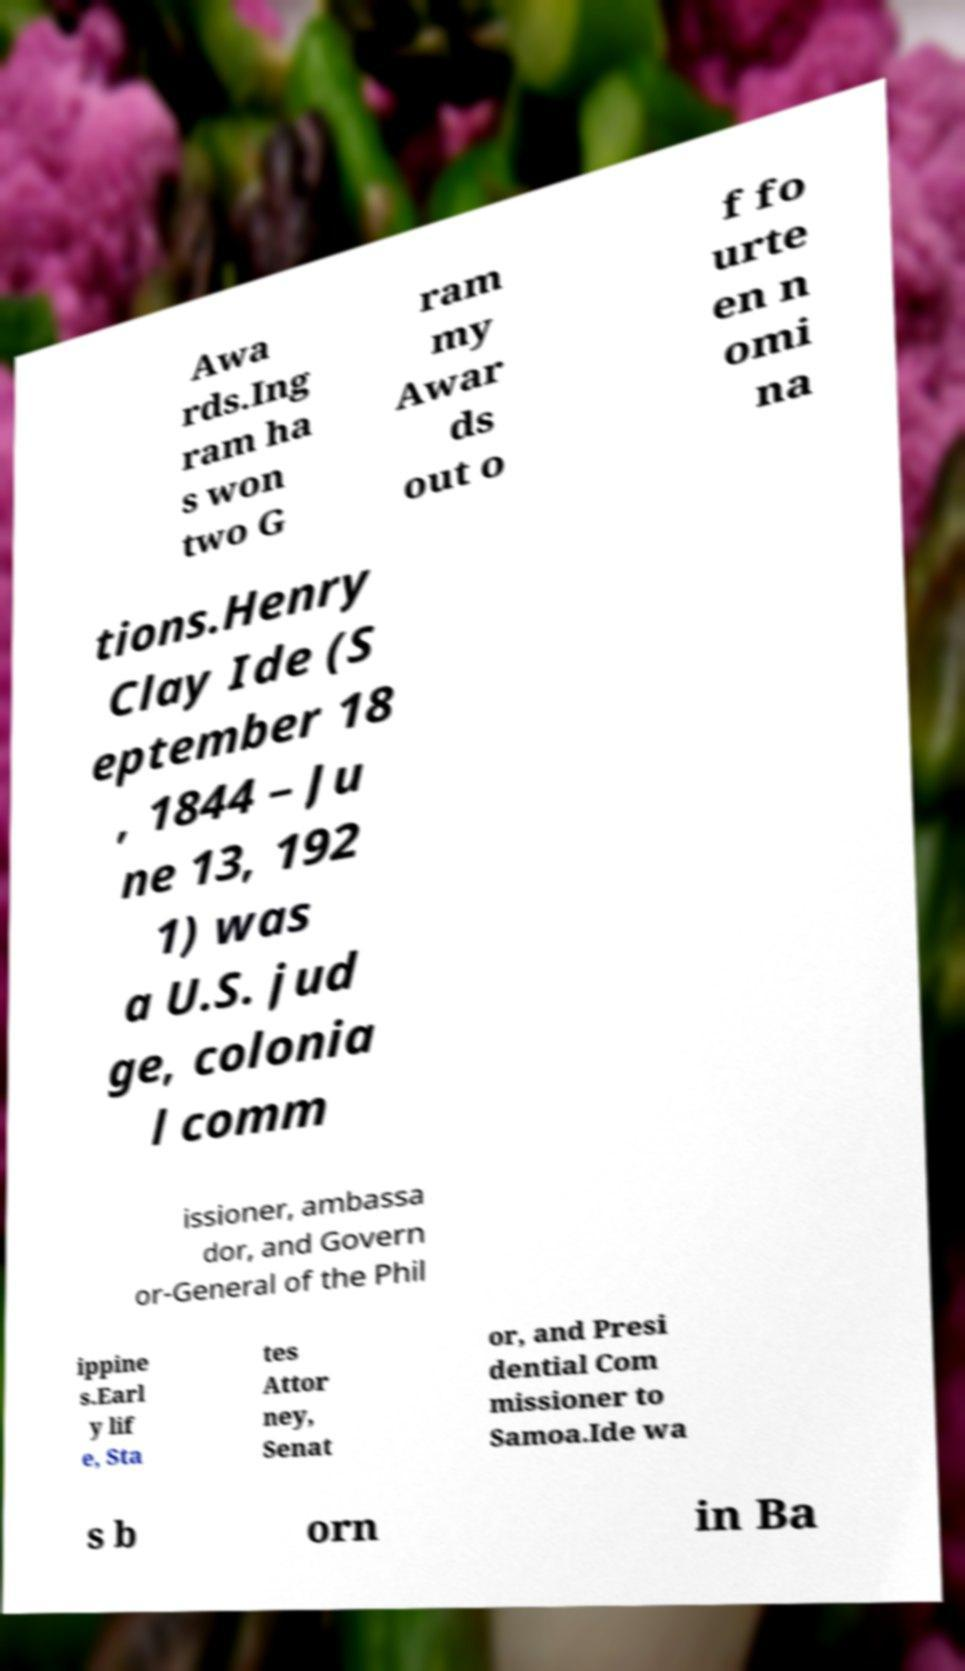Please read and relay the text visible in this image. What does it say? Awa rds.Ing ram ha s won two G ram my Awar ds out o f fo urte en n omi na tions.Henry Clay Ide (S eptember 18 , 1844 – Ju ne 13, 192 1) was a U.S. jud ge, colonia l comm issioner, ambassa dor, and Govern or-General of the Phil ippine s.Earl y lif e, Sta tes Attor ney, Senat or, and Presi dential Com missioner to Samoa.Ide wa s b orn in Ba 